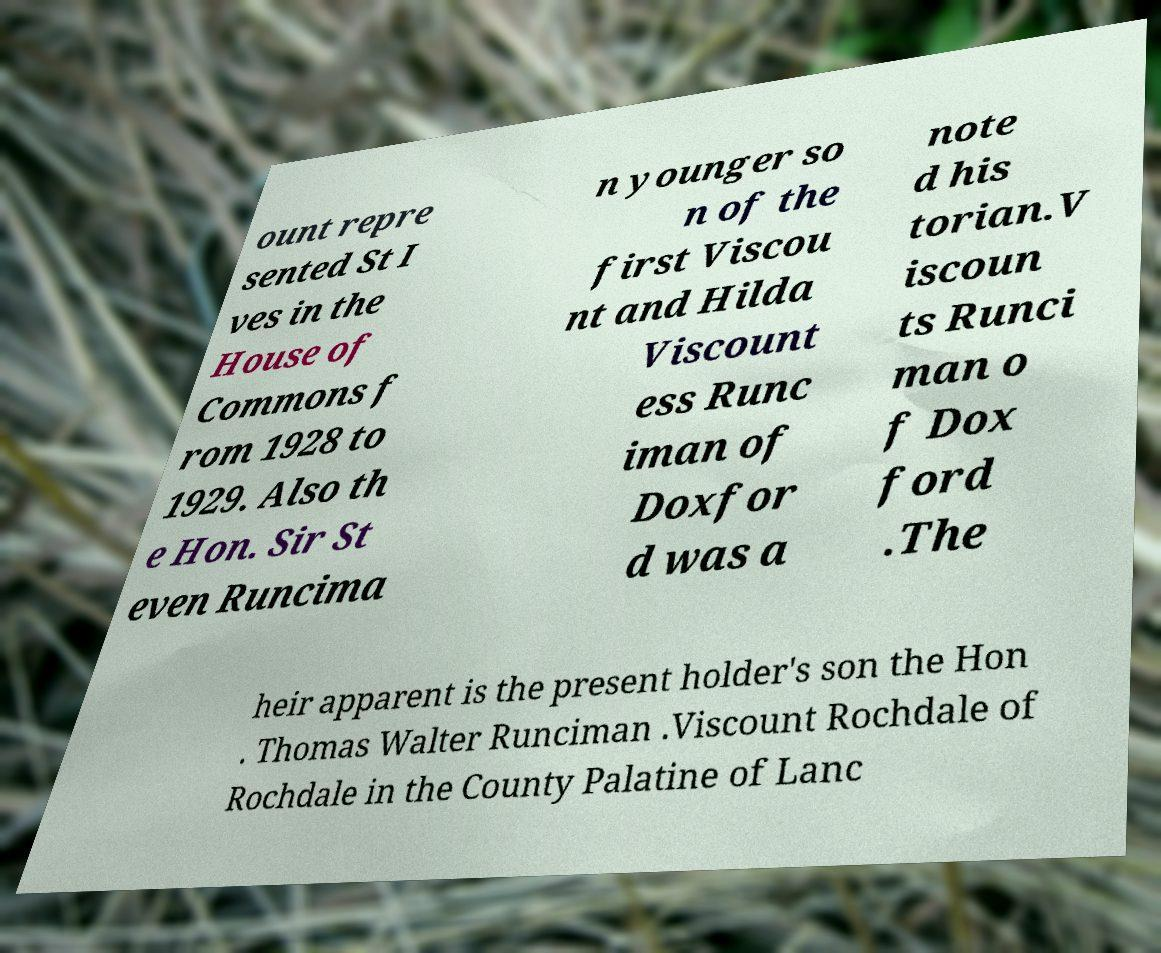Could you extract and type out the text from this image? ount repre sented St I ves in the House of Commons f rom 1928 to 1929. Also th e Hon. Sir St even Runcima n younger so n of the first Viscou nt and Hilda Viscount ess Runc iman of Doxfor d was a note d his torian.V iscoun ts Runci man o f Dox ford .The heir apparent is the present holder's son the Hon . Thomas Walter Runciman .Viscount Rochdale of Rochdale in the County Palatine of Lanc 